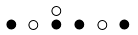<formula> <loc_0><loc_0><loc_500><loc_500>\begin{smallmatrix} & & \circ \\ \bullet & \circ & \bullet & \bullet & \circ & \bullet & \\ \end{smallmatrix}</formula> 